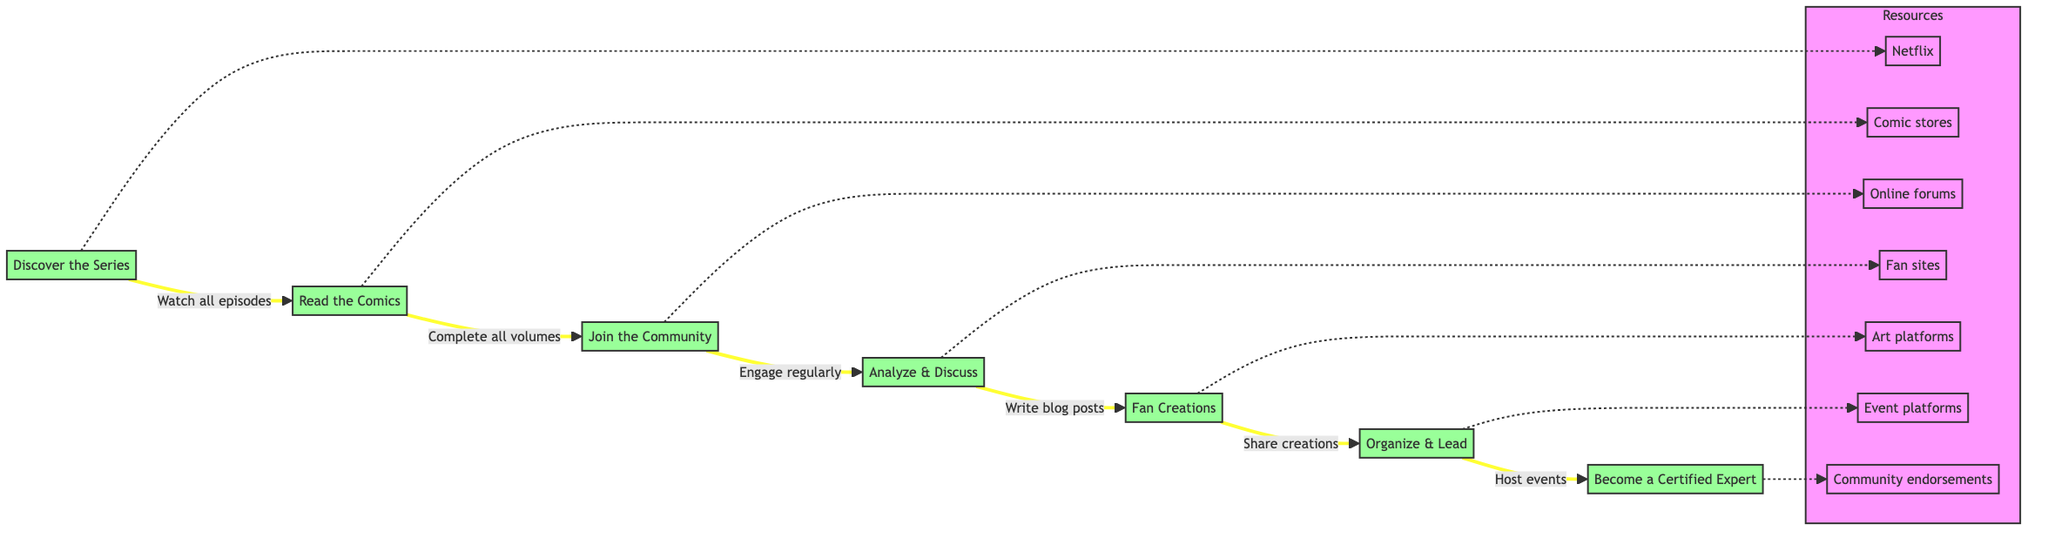What is the first stage in becoming a certified Locke & Key expert? The first stage listed in the diagram is "Discover the Series".
Answer: Discover the Series How many total stages are there in the flowchart? The flowchart outlines 7 stages in total, from "Discover the Series" to "Become a Certified Expert".
Answer: 7 What is the action associated with the "Join the Community" stage? The action specified for the "Join the Community" stage is "Engage regularly".
Answer: Engage regularly What resource is linked to the "Fan Creations" stage? The resource associated with the "Fan Creations" stage is "Art platforms".
Answer: Art platforms Which two stages require you to share something? The stages "Fan Creations" and "Organize & Lead" both involve sharing; specifically, sharing creations and hosting events, respectively.
Answer: Fan Creations and Organize & Lead What stage comes after analyzing and discussing? The stage that follows "Analyze & Discuss" is "Fan Creations".
Answer: Fan Creations What is the relationship between "Organize & Lead" and "Become a Certified Expert"? The relationship is that "Organize & Lead" is a prerequisite step to "Become a Certified Expert", as one must host events before gaining expert status.
Answer: Prerequisite How is the "Become a Certified Expert" stage achieved? Recognition as a "Locke & Key" expert is obtained by "Gathering endorsements" from community members.
Answer: Gather endorsements What is the main purpose of joining the community according to the flowchart? The main purpose of joining the community is to "Engage regularly" with other fans.
Answer: Engage regularly 